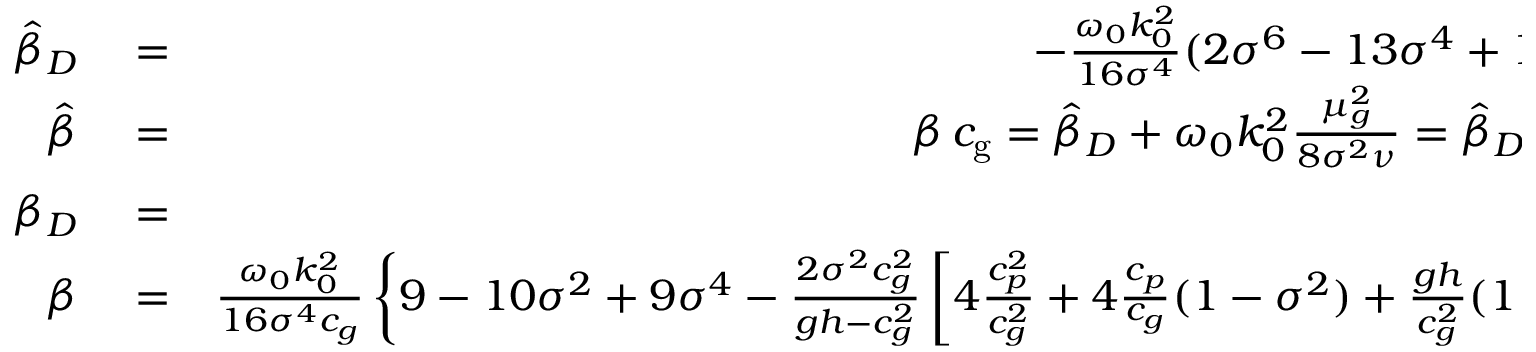Convert formula to latex. <formula><loc_0><loc_0><loc_500><loc_500>\begin{array} { r l r } { \hat { \beta } _ { D } } & = } & { - \frac { \omega _ { 0 } k _ { 0 } ^ { 2 } } { 1 6 \sigma ^ { 4 } } ( 2 \sigma ^ { 6 } - 1 3 \sigma ^ { 4 } + 1 2 \sigma ^ { 2 } - 9 ) } \\ { \hat { \beta } } & = } & { \beta \, { c _ { g } } = \hat { \beta } _ { D } + \omega _ { 0 } k _ { 0 } ^ { 2 } \frac { \mu _ { g } ^ { 2 } } { 8 \sigma ^ { 2 } \nu } = \hat { \beta } _ { D } - \frac { k _ { 0 } \mu _ { g } } { 4 \sigma h } D } \\ { \beta _ { D } } & = } & { \frac { \hat { \beta } _ { D } } { c _ { g } } } \\ { \beta } & = } & { \frac { \omega _ { 0 } k _ { 0 } ^ { 2 } } { 1 6 \sigma ^ { 4 } c _ { g } } \left \{ 9 - 1 0 \sigma ^ { 2 } + 9 \sigma ^ { 4 } - \frac { 2 \sigma ^ { 2 } c _ { g } ^ { 2 } } { g h - c _ { g } ^ { 2 } } \left [ 4 \frac { c _ { p } ^ { 2 } } { c _ { g } ^ { 2 } } + 4 \frac { c _ { p } } { c _ { g } } ( 1 - \sigma ^ { 2 } ) + \frac { g h } { c _ { g } ^ { 2 } } ( 1 - \sigma ^ { 2 } ) ^ { 2 } \right ] \right \} } \end{array}</formula> 